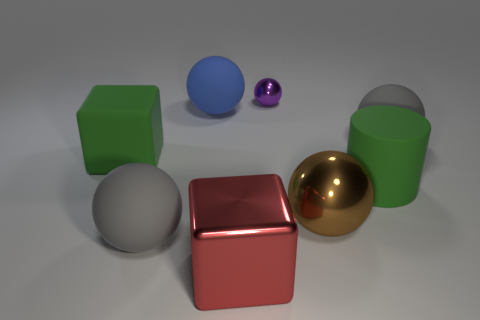Subtract all blue balls. How many balls are left? 4 Subtract all small balls. How many balls are left? 4 Add 1 big green rubber objects. How many objects exist? 9 Subtract all red spheres. Subtract all purple cylinders. How many spheres are left? 5 Subtract all cylinders. How many objects are left? 7 Add 8 large green cubes. How many large green cubes are left? 9 Add 3 cylinders. How many cylinders exist? 4 Subtract 0 cyan balls. How many objects are left? 8 Subtract all big green objects. Subtract all small purple metallic spheres. How many objects are left? 5 